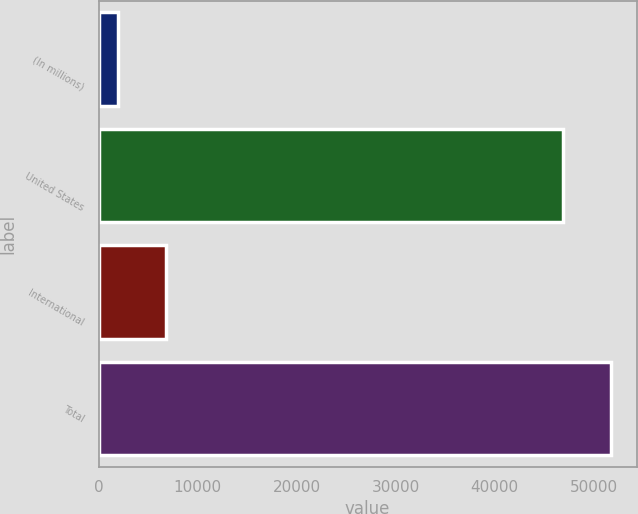<chart> <loc_0><loc_0><loc_500><loc_500><bar_chart><fcel>(In millions)<fcel>United States<fcel>International<fcel>Total<nl><fcel>2002<fcel>46966.7<fcel>6800.61<fcel>51765.3<nl></chart> 